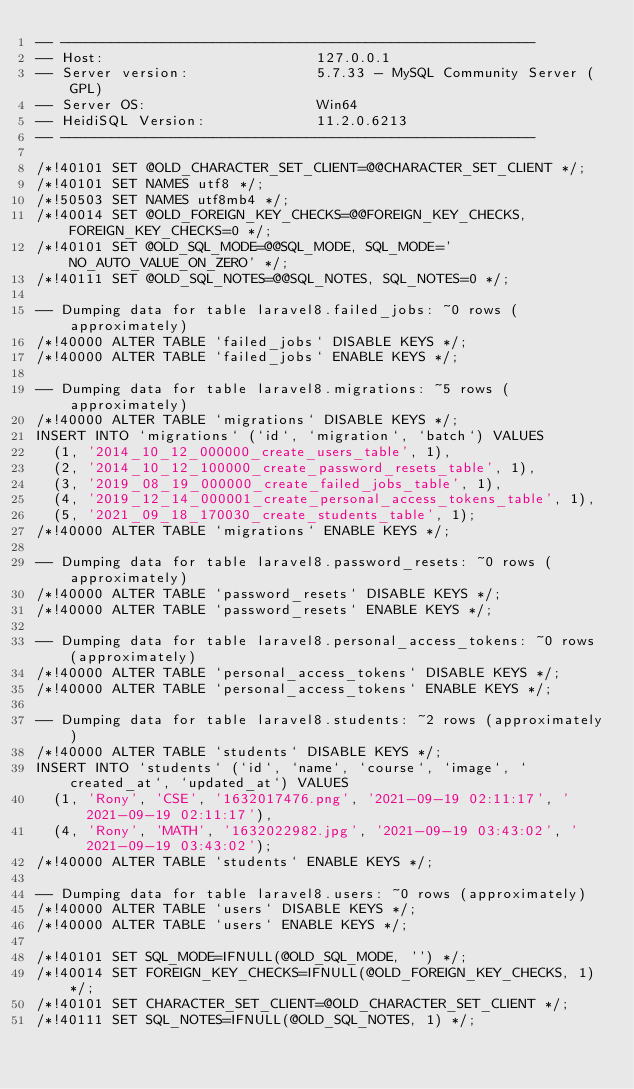Convert code to text. <code><loc_0><loc_0><loc_500><loc_500><_SQL_>-- --------------------------------------------------------
-- Host:                         127.0.0.1
-- Server version:               5.7.33 - MySQL Community Server (GPL)
-- Server OS:                    Win64
-- HeidiSQL Version:             11.2.0.6213
-- --------------------------------------------------------

/*!40101 SET @OLD_CHARACTER_SET_CLIENT=@@CHARACTER_SET_CLIENT */;
/*!40101 SET NAMES utf8 */;
/*!50503 SET NAMES utf8mb4 */;
/*!40014 SET @OLD_FOREIGN_KEY_CHECKS=@@FOREIGN_KEY_CHECKS, FOREIGN_KEY_CHECKS=0 */;
/*!40101 SET @OLD_SQL_MODE=@@SQL_MODE, SQL_MODE='NO_AUTO_VALUE_ON_ZERO' */;
/*!40111 SET @OLD_SQL_NOTES=@@SQL_NOTES, SQL_NOTES=0 */;

-- Dumping data for table laravel8.failed_jobs: ~0 rows (approximately)
/*!40000 ALTER TABLE `failed_jobs` DISABLE KEYS */;
/*!40000 ALTER TABLE `failed_jobs` ENABLE KEYS */;

-- Dumping data for table laravel8.migrations: ~5 rows (approximately)
/*!40000 ALTER TABLE `migrations` DISABLE KEYS */;
INSERT INTO `migrations` (`id`, `migration`, `batch`) VALUES
	(1, '2014_10_12_000000_create_users_table', 1),
	(2, '2014_10_12_100000_create_password_resets_table', 1),
	(3, '2019_08_19_000000_create_failed_jobs_table', 1),
	(4, '2019_12_14_000001_create_personal_access_tokens_table', 1),
	(5, '2021_09_18_170030_create_students_table', 1);
/*!40000 ALTER TABLE `migrations` ENABLE KEYS */;

-- Dumping data for table laravel8.password_resets: ~0 rows (approximately)
/*!40000 ALTER TABLE `password_resets` DISABLE KEYS */;
/*!40000 ALTER TABLE `password_resets` ENABLE KEYS */;

-- Dumping data for table laravel8.personal_access_tokens: ~0 rows (approximately)
/*!40000 ALTER TABLE `personal_access_tokens` DISABLE KEYS */;
/*!40000 ALTER TABLE `personal_access_tokens` ENABLE KEYS */;

-- Dumping data for table laravel8.students: ~2 rows (approximately)
/*!40000 ALTER TABLE `students` DISABLE KEYS */;
INSERT INTO `students` (`id`, `name`, `course`, `image`, `created_at`, `updated_at`) VALUES
	(1, 'Rony', 'CSE', '1632017476.png', '2021-09-19 02:11:17', '2021-09-19 02:11:17'),
	(4, 'Rony', 'MATH', '1632022982.jpg', '2021-09-19 03:43:02', '2021-09-19 03:43:02');
/*!40000 ALTER TABLE `students` ENABLE KEYS */;

-- Dumping data for table laravel8.users: ~0 rows (approximately)
/*!40000 ALTER TABLE `users` DISABLE KEYS */;
/*!40000 ALTER TABLE `users` ENABLE KEYS */;

/*!40101 SET SQL_MODE=IFNULL(@OLD_SQL_MODE, '') */;
/*!40014 SET FOREIGN_KEY_CHECKS=IFNULL(@OLD_FOREIGN_KEY_CHECKS, 1) */;
/*!40101 SET CHARACTER_SET_CLIENT=@OLD_CHARACTER_SET_CLIENT */;
/*!40111 SET SQL_NOTES=IFNULL(@OLD_SQL_NOTES, 1) */;
</code> 